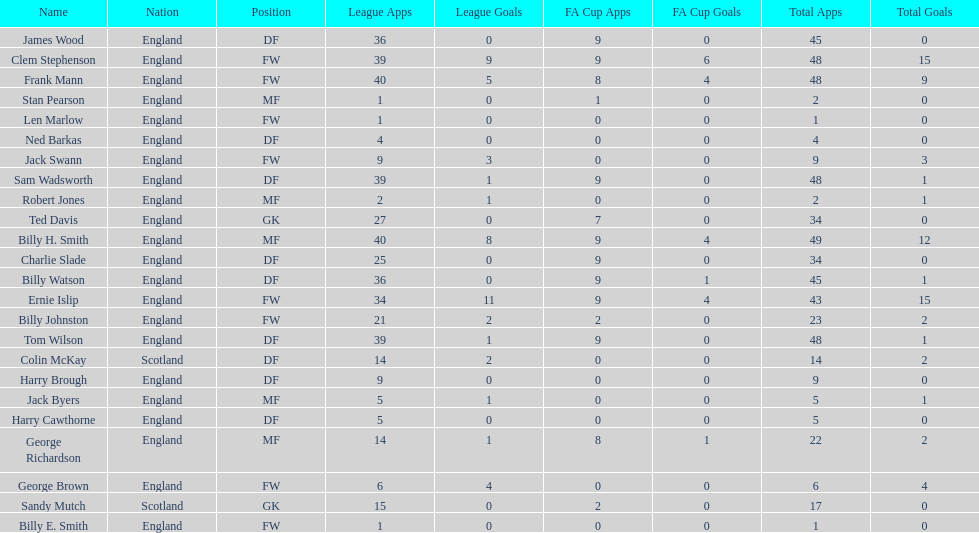What are the number of league apps ted davis has? 27. 